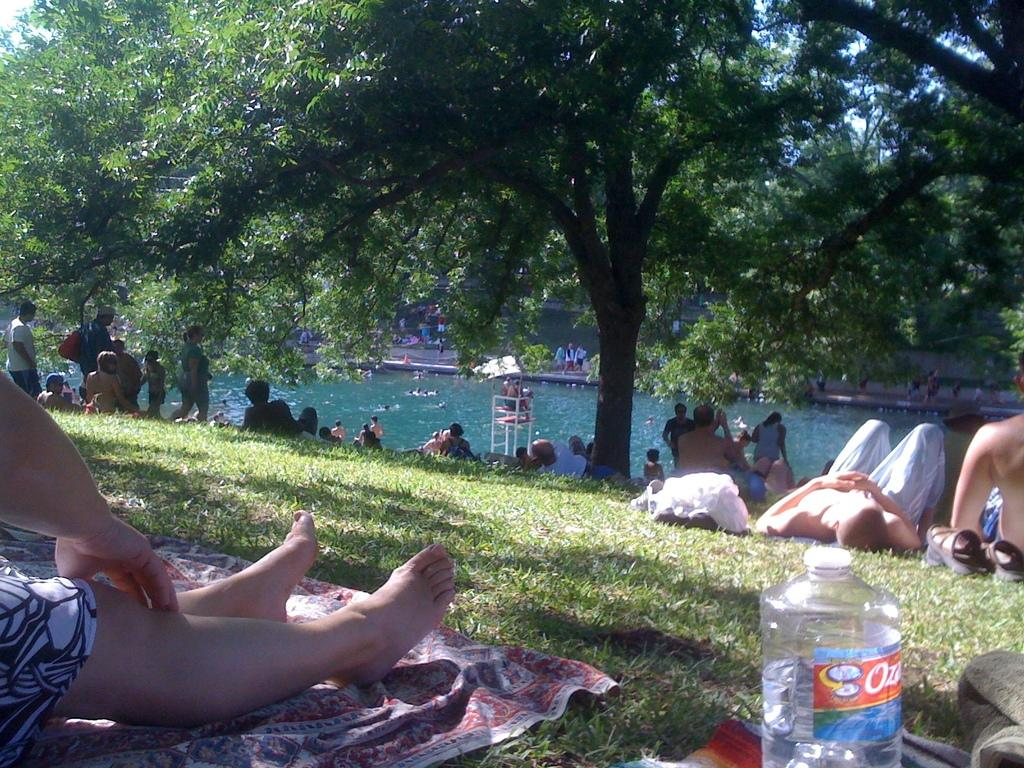What are the people in the image doing? The people in the image are resting on the ground. What type of surface are they resting on? They are resting on grass, which is visible in the image. What objects can be seen on the floor in the image? There are objects on the floor in the image. What can be seen in the background of the image? There are trees and water visible in the background of the image. What type of bead is being used to decorate the alley in the image? There is no alley or bead present in the image. Can you tell me how the people in the image are taking a selfie? There is no indication in the image that the people are taking a selfie. 